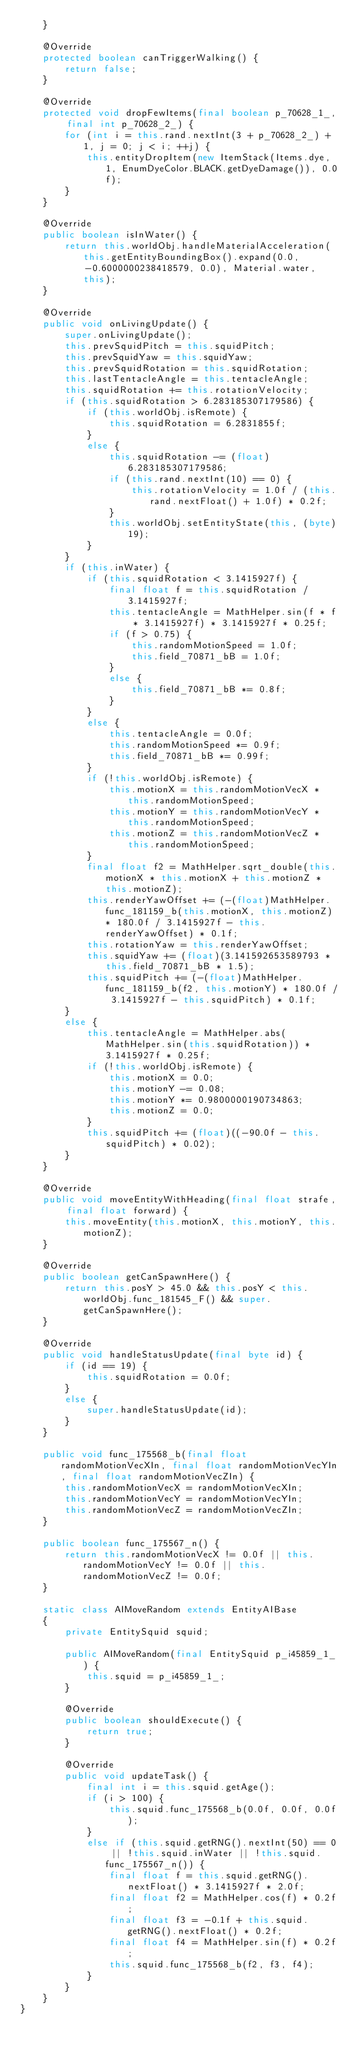Convert code to text. <code><loc_0><loc_0><loc_500><loc_500><_Java_>    }
    
    @Override
    protected boolean canTriggerWalking() {
        return false;
    }
    
    @Override
    protected void dropFewItems(final boolean p_70628_1_, final int p_70628_2_) {
        for (int i = this.rand.nextInt(3 + p_70628_2_) + 1, j = 0; j < i; ++j) {
            this.entityDropItem(new ItemStack(Items.dye, 1, EnumDyeColor.BLACK.getDyeDamage()), 0.0f);
        }
    }
    
    @Override
    public boolean isInWater() {
        return this.worldObj.handleMaterialAcceleration(this.getEntityBoundingBox().expand(0.0, -0.6000000238418579, 0.0), Material.water, this);
    }
    
    @Override
    public void onLivingUpdate() {
        super.onLivingUpdate();
        this.prevSquidPitch = this.squidPitch;
        this.prevSquidYaw = this.squidYaw;
        this.prevSquidRotation = this.squidRotation;
        this.lastTentacleAngle = this.tentacleAngle;
        this.squidRotation += this.rotationVelocity;
        if (this.squidRotation > 6.283185307179586) {
            if (this.worldObj.isRemote) {
                this.squidRotation = 6.2831855f;
            }
            else {
                this.squidRotation -= (float)6.283185307179586;
                if (this.rand.nextInt(10) == 0) {
                    this.rotationVelocity = 1.0f / (this.rand.nextFloat() + 1.0f) * 0.2f;
                }
                this.worldObj.setEntityState(this, (byte)19);
            }
        }
        if (this.inWater) {
            if (this.squidRotation < 3.1415927f) {
                final float f = this.squidRotation / 3.1415927f;
                this.tentacleAngle = MathHelper.sin(f * f * 3.1415927f) * 3.1415927f * 0.25f;
                if (f > 0.75) {
                    this.randomMotionSpeed = 1.0f;
                    this.field_70871_bB = 1.0f;
                }
                else {
                    this.field_70871_bB *= 0.8f;
                }
            }
            else {
                this.tentacleAngle = 0.0f;
                this.randomMotionSpeed *= 0.9f;
                this.field_70871_bB *= 0.99f;
            }
            if (!this.worldObj.isRemote) {
                this.motionX = this.randomMotionVecX * this.randomMotionSpeed;
                this.motionY = this.randomMotionVecY * this.randomMotionSpeed;
                this.motionZ = this.randomMotionVecZ * this.randomMotionSpeed;
            }
            final float f2 = MathHelper.sqrt_double(this.motionX * this.motionX + this.motionZ * this.motionZ);
            this.renderYawOffset += (-(float)MathHelper.func_181159_b(this.motionX, this.motionZ) * 180.0f / 3.1415927f - this.renderYawOffset) * 0.1f;
            this.rotationYaw = this.renderYawOffset;
            this.squidYaw += (float)(3.141592653589793 * this.field_70871_bB * 1.5);
            this.squidPitch += (-(float)MathHelper.func_181159_b(f2, this.motionY) * 180.0f / 3.1415927f - this.squidPitch) * 0.1f;
        }
        else {
            this.tentacleAngle = MathHelper.abs(MathHelper.sin(this.squidRotation)) * 3.1415927f * 0.25f;
            if (!this.worldObj.isRemote) {
                this.motionX = 0.0;
                this.motionY -= 0.08;
                this.motionY *= 0.9800000190734863;
                this.motionZ = 0.0;
            }
            this.squidPitch += (float)((-90.0f - this.squidPitch) * 0.02);
        }
    }
    
    @Override
    public void moveEntityWithHeading(final float strafe, final float forward) {
        this.moveEntity(this.motionX, this.motionY, this.motionZ);
    }
    
    @Override
    public boolean getCanSpawnHere() {
        return this.posY > 45.0 && this.posY < this.worldObj.func_181545_F() && super.getCanSpawnHere();
    }
    
    @Override
    public void handleStatusUpdate(final byte id) {
        if (id == 19) {
            this.squidRotation = 0.0f;
        }
        else {
            super.handleStatusUpdate(id);
        }
    }
    
    public void func_175568_b(final float randomMotionVecXIn, final float randomMotionVecYIn, final float randomMotionVecZIn) {
        this.randomMotionVecX = randomMotionVecXIn;
        this.randomMotionVecY = randomMotionVecYIn;
        this.randomMotionVecZ = randomMotionVecZIn;
    }
    
    public boolean func_175567_n() {
        return this.randomMotionVecX != 0.0f || this.randomMotionVecY != 0.0f || this.randomMotionVecZ != 0.0f;
    }
    
    static class AIMoveRandom extends EntityAIBase
    {
        private EntitySquid squid;
        
        public AIMoveRandom(final EntitySquid p_i45859_1_) {
            this.squid = p_i45859_1_;
        }
        
        @Override
        public boolean shouldExecute() {
            return true;
        }
        
        @Override
        public void updateTask() {
            final int i = this.squid.getAge();
            if (i > 100) {
                this.squid.func_175568_b(0.0f, 0.0f, 0.0f);
            }
            else if (this.squid.getRNG().nextInt(50) == 0 || !this.squid.inWater || !this.squid.func_175567_n()) {
                final float f = this.squid.getRNG().nextFloat() * 3.1415927f * 2.0f;
                final float f2 = MathHelper.cos(f) * 0.2f;
                final float f3 = -0.1f + this.squid.getRNG().nextFloat() * 0.2f;
                final float f4 = MathHelper.sin(f) * 0.2f;
                this.squid.func_175568_b(f2, f3, f4);
            }
        }
    }
}
</code> 